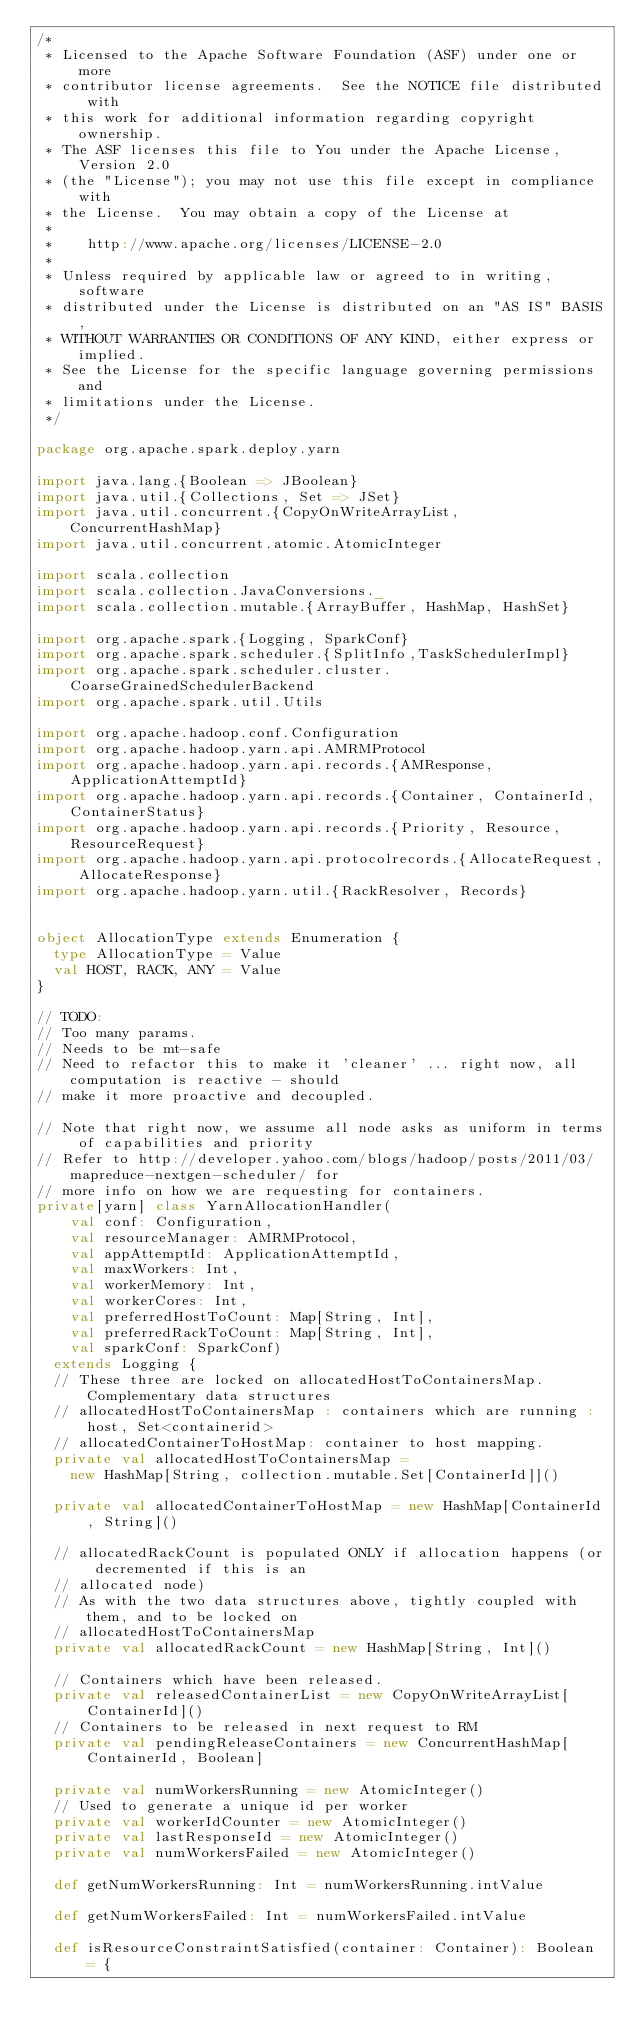<code> <loc_0><loc_0><loc_500><loc_500><_Scala_>/*
 * Licensed to the Apache Software Foundation (ASF) under one or more
 * contributor license agreements.  See the NOTICE file distributed with
 * this work for additional information regarding copyright ownership.
 * The ASF licenses this file to You under the Apache License, Version 2.0
 * (the "License"); you may not use this file except in compliance with
 * the License.  You may obtain a copy of the License at
 *
 *    http://www.apache.org/licenses/LICENSE-2.0
 *
 * Unless required by applicable law or agreed to in writing, software
 * distributed under the License is distributed on an "AS IS" BASIS,
 * WITHOUT WARRANTIES OR CONDITIONS OF ANY KIND, either express or implied.
 * See the License for the specific language governing permissions and
 * limitations under the License.
 */

package org.apache.spark.deploy.yarn

import java.lang.{Boolean => JBoolean}
import java.util.{Collections, Set => JSet}
import java.util.concurrent.{CopyOnWriteArrayList, ConcurrentHashMap}
import java.util.concurrent.atomic.AtomicInteger

import scala.collection
import scala.collection.JavaConversions._
import scala.collection.mutable.{ArrayBuffer, HashMap, HashSet}

import org.apache.spark.{Logging, SparkConf}
import org.apache.spark.scheduler.{SplitInfo,TaskSchedulerImpl}
import org.apache.spark.scheduler.cluster.CoarseGrainedSchedulerBackend
import org.apache.spark.util.Utils

import org.apache.hadoop.conf.Configuration
import org.apache.hadoop.yarn.api.AMRMProtocol
import org.apache.hadoop.yarn.api.records.{AMResponse, ApplicationAttemptId}
import org.apache.hadoop.yarn.api.records.{Container, ContainerId, ContainerStatus}
import org.apache.hadoop.yarn.api.records.{Priority, Resource, ResourceRequest}
import org.apache.hadoop.yarn.api.protocolrecords.{AllocateRequest, AllocateResponse}
import org.apache.hadoop.yarn.util.{RackResolver, Records}


object AllocationType extends Enumeration {
  type AllocationType = Value
  val HOST, RACK, ANY = Value
}

// TODO:
// Too many params.
// Needs to be mt-safe
// Need to refactor this to make it 'cleaner' ... right now, all computation is reactive - should
// make it more proactive and decoupled.

// Note that right now, we assume all node asks as uniform in terms of capabilities and priority
// Refer to http://developer.yahoo.com/blogs/hadoop/posts/2011/03/mapreduce-nextgen-scheduler/ for
// more info on how we are requesting for containers.
private[yarn] class YarnAllocationHandler(
    val conf: Configuration,
    val resourceManager: AMRMProtocol, 
    val appAttemptId: ApplicationAttemptId,
    val maxWorkers: Int,
    val workerMemory: Int,
    val workerCores: Int,
    val preferredHostToCount: Map[String, Int], 
    val preferredRackToCount: Map[String, Int],
    val sparkConf: SparkConf)
  extends Logging {
  // These three are locked on allocatedHostToContainersMap. Complementary data structures
  // allocatedHostToContainersMap : containers which are running : host, Set<containerid>
  // allocatedContainerToHostMap: container to host mapping.
  private val allocatedHostToContainersMap =
    new HashMap[String, collection.mutable.Set[ContainerId]]()

  private val allocatedContainerToHostMap = new HashMap[ContainerId, String]()

  // allocatedRackCount is populated ONLY if allocation happens (or decremented if this is an
  // allocated node)
  // As with the two data structures above, tightly coupled with them, and to be locked on
  // allocatedHostToContainersMap
  private val allocatedRackCount = new HashMap[String, Int]()

  // Containers which have been released.
  private val releasedContainerList = new CopyOnWriteArrayList[ContainerId]()
  // Containers to be released in next request to RM
  private val pendingReleaseContainers = new ConcurrentHashMap[ContainerId, Boolean]

  private val numWorkersRunning = new AtomicInteger()
  // Used to generate a unique id per worker
  private val workerIdCounter = new AtomicInteger()
  private val lastResponseId = new AtomicInteger()
  private val numWorkersFailed = new AtomicInteger()

  def getNumWorkersRunning: Int = numWorkersRunning.intValue

  def getNumWorkersFailed: Int = numWorkersFailed.intValue

  def isResourceConstraintSatisfied(container: Container): Boolean = {</code> 